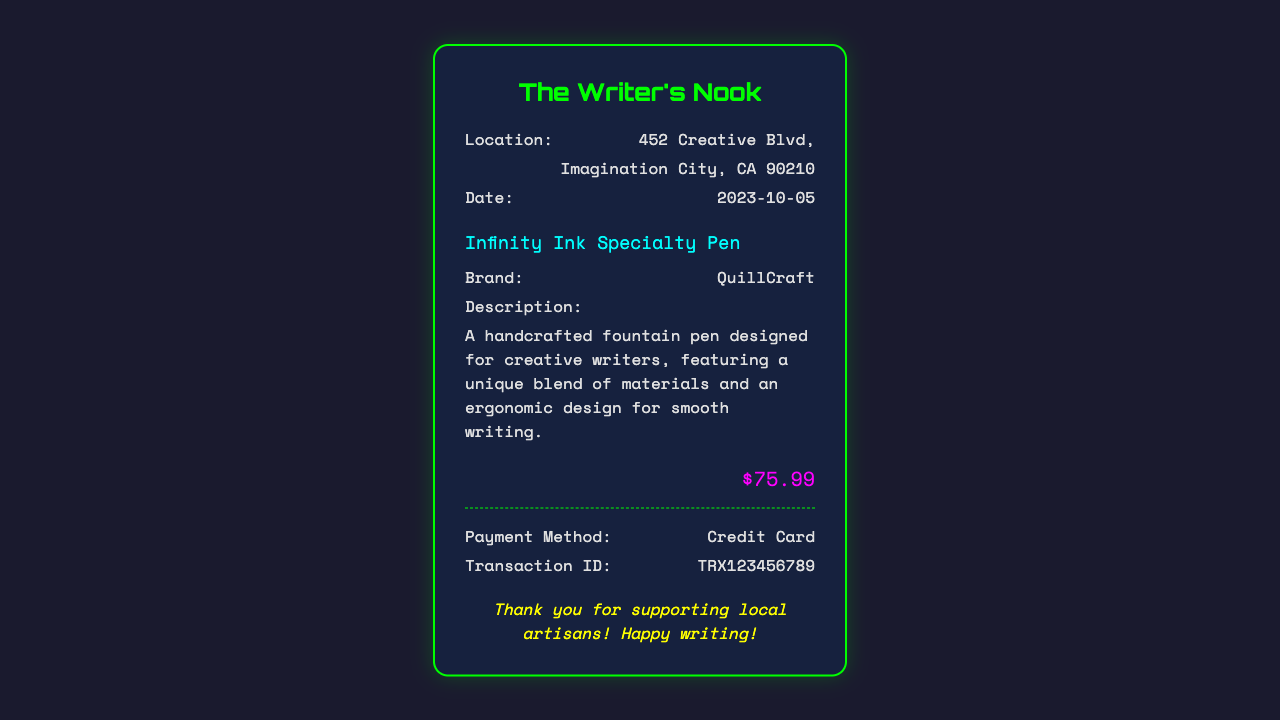What is the store name? The store's name is displayed prominently at the top of the receipt.
Answer: The Writer's Nook What is the item purchased? The specific item is mentioned just before the details section in the receipt.
Answer: Infinity Ink Specialty Pen What is the price of the pen? The price is provided in a larger font size and highlighted at the bottom of the receipt.
Answer: $75.99 Where is the store located? The location details are printed within the receipt under the store name.
Answer: 452 Creative Blvd, Imagination City, CA 90210 What brand is the pen? The brand name is listed under the item details on the receipt.
Answer: QuillCraft When was the purchase made? The date of the purchase is specified in the detail section of the receipt.
Answer: 2023-10-05 What was the payment method? The method used for payment is displayed at the bottom of the receipt.
Answer: Credit Card What is the transaction ID? The unique identifier for the transaction is included in the financial details section.
Answer: TRX123456789 What is the description of the pen? The description provides insight about the pen's features and is found in the details section.
Answer: A handcrafted fountain pen designed for creative writers, featuring a unique blend of materials and an ergonomic design for smooth writing 